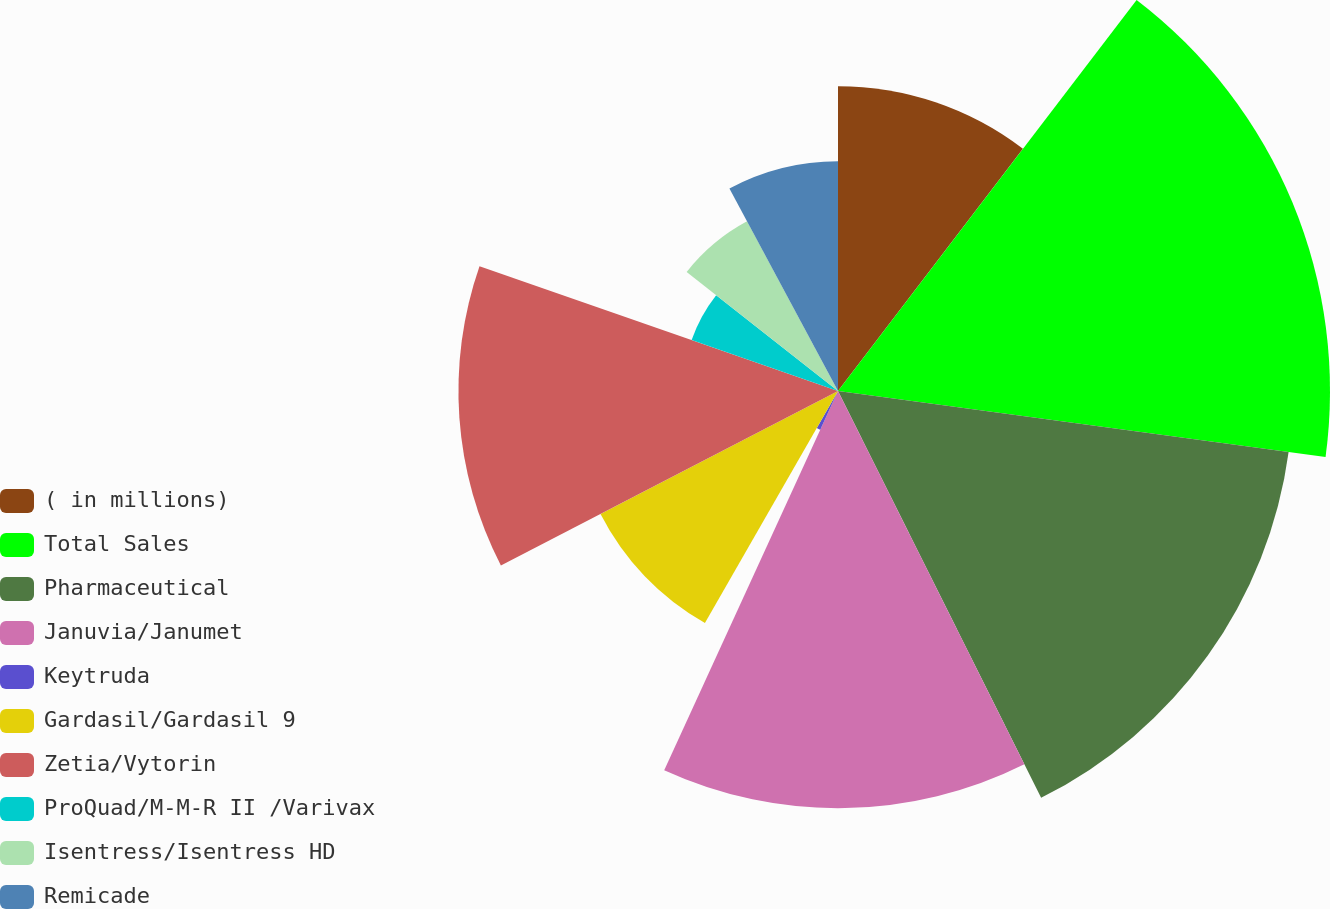Convert chart to OTSL. <chart><loc_0><loc_0><loc_500><loc_500><pie_chart><fcel>( in millions)<fcel>Total Sales<fcel>Pharmaceutical<fcel>Januvia/Janumet<fcel>Keytruda<fcel>Gardasil/Gardasil 9<fcel>Zetia/Vytorin<fcel>ProQuad/M-M-R II /Varivax<fcel>Isentress/Isentress HD<fcel>Remicade<nl><fcel>10.38%<fcel>16.76%<fcel>15.49%<fcel>14.21%<fcel>1.45%<fcel>9.11%<fcel>12.93%<fcel>5.28%<fcel>6.56%<fcel>7.83%<nl></chart> 